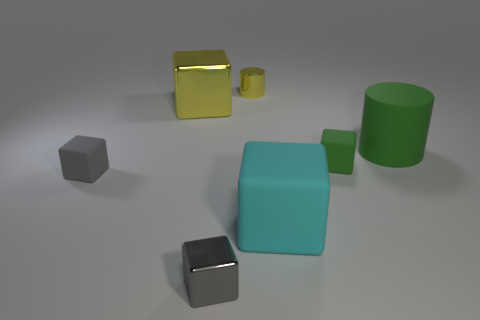Subtract all green cubes. How many cubes are left? 4 Subtract all gray balls. How many gray blocks are left? 2 Add 2 shiny cubes. How many objects exist? 9 Subtract 3 cubes. How many cubes are left? 2 Subtract all cylinders. How many objects are left? 5 Subtract all gray blocks. How many blocks are left? 3 Subtract 0 brown spheres. How many objects are left? 7 Subtract all green cylinders. Subtract all gray cubes. How many cylinders are left? 1 Subtract all small gray cubes. Subtract all small green objects. How many objects are left? 4 Add 2 big shiny cubes. How many big shiny cubes are left? 3 